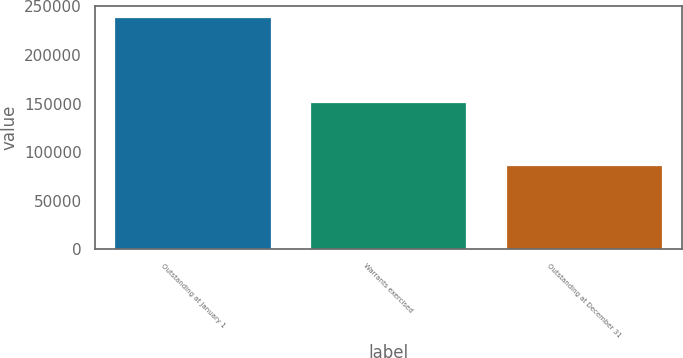Convert chart. <chart><loc_0><loc_0><loc_500><loc_500><bar_chart><fcel>Outstanding at January 1<fcel>Warrants exercised<fcel>Outstanding at December 31<nl><fcel>238703<fcel>151554<fcel>87149<nl></chart> 